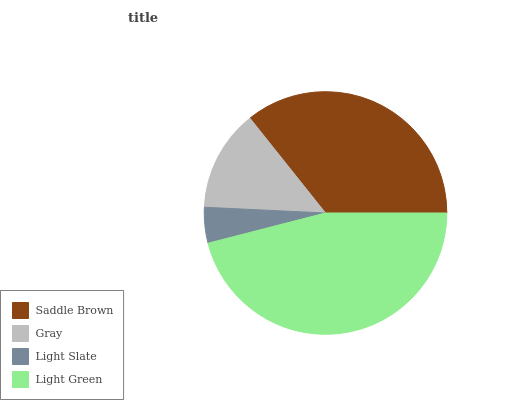Is Light Slate the minimum?
Answer yes or no. Yes. Is Light Green the maximum?
Answer yes or no. Yes. Is Gray the minimum?
Answer yes or no. No. Is Gray the maximum?
Answer yes or no. No. Is Saddle Brown greater than Gray?
Answer yes or no. Yes. Is Gray less than Saddle Brown?
Answer yes or no. Yes. Is Gray greater than Saddle Brown?
Answer yes or no. No. Is Saddle Brown less than Gray?
Answer yes or no. No. Is Saddle Brown the high median?
Answer yes or no. Yes. Is Gray the low median?
Answer yes or no. Yes. Is Light Slate the high median?
Answer yes or no. No. Is Light Slate the low median?
Answer yes or no. No. 